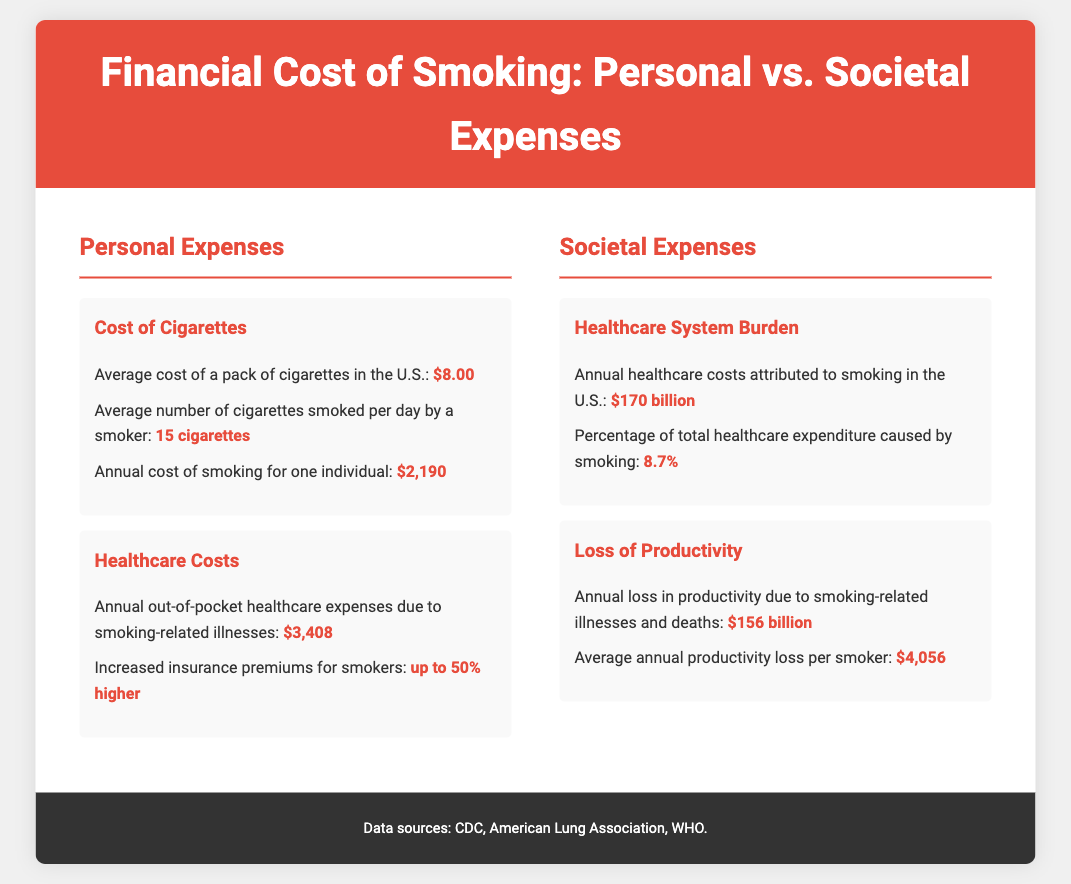what is the average cost of a pack of cigarettes in the U.S.? The average cost of a pack of cigarettes in the U.S. is explicitly stated in the document.
Answer: $8.00 what is the average number of cigarettes smoked per day by a smoker? The document provides the average number of cigarettes smoked daily by a smoker.
Answer: 15 cigarettes what are the annual healthcare costs attributed to smoking in the U.S.? The annual healthcare costs attributed to smoking are detailed in the societal expenses section.
Answer: $170 billion how much is the average annual productivity loss per smoker? The document indicates the average annual productivity loss per smoker in the relevant subsection.
Answer: $4,056 what is the percentage of total healthcare expenditure caused by smoking? This percentage is provided in the healthcare system burden subsection of the document.
Answer: 8.7% which has a higher personal expense: cost of cigarettes or annual out-of-pocket healthcare expenses? A comparison is made between the cost of cigarettes and healthcare expenses in the personal expenses section.
Answer: Annual out-of-pocket healthcare expenses what is the total annual cost of smoking for one individual? The annual cost of smoking for one individual is explicitly mentioned in the personal expenses section.
Answer: $2,190 what is the total annual loss in productivity due to smoking-related illnesses and deaths? The document lists this total loss in the loss of productivity subsection.
Answer: $156 billion how much higher are insurance premiums for smokers compared to non-smokers? The document specifies a percentage increase in insurance premiums for smokers in the healthcare costs subsection.
Answer: up to 50% higher 